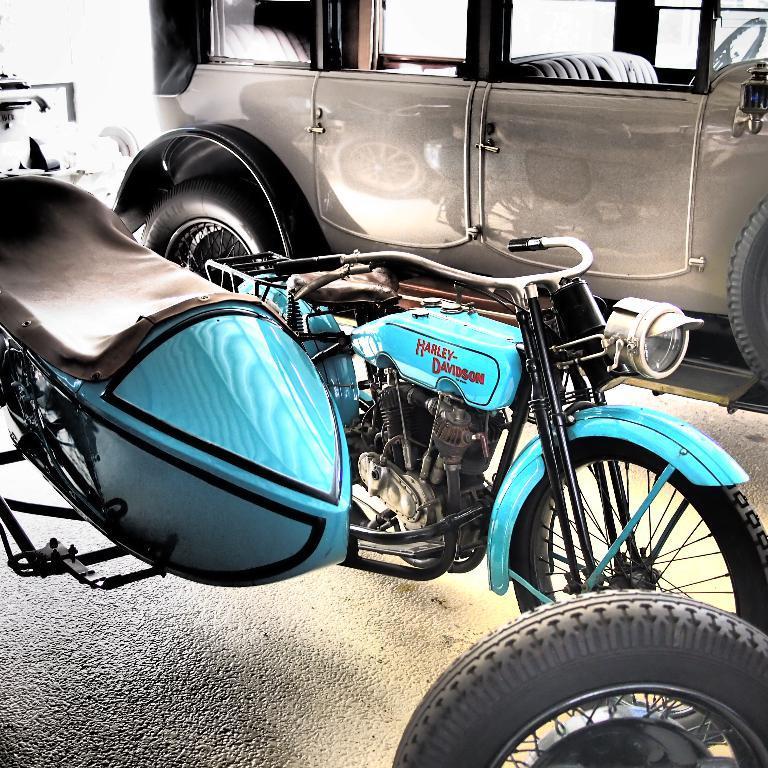Describe this image in one or two sentences. In this image I can see a bike in blue color, at the top it looks like a car in grey color. 